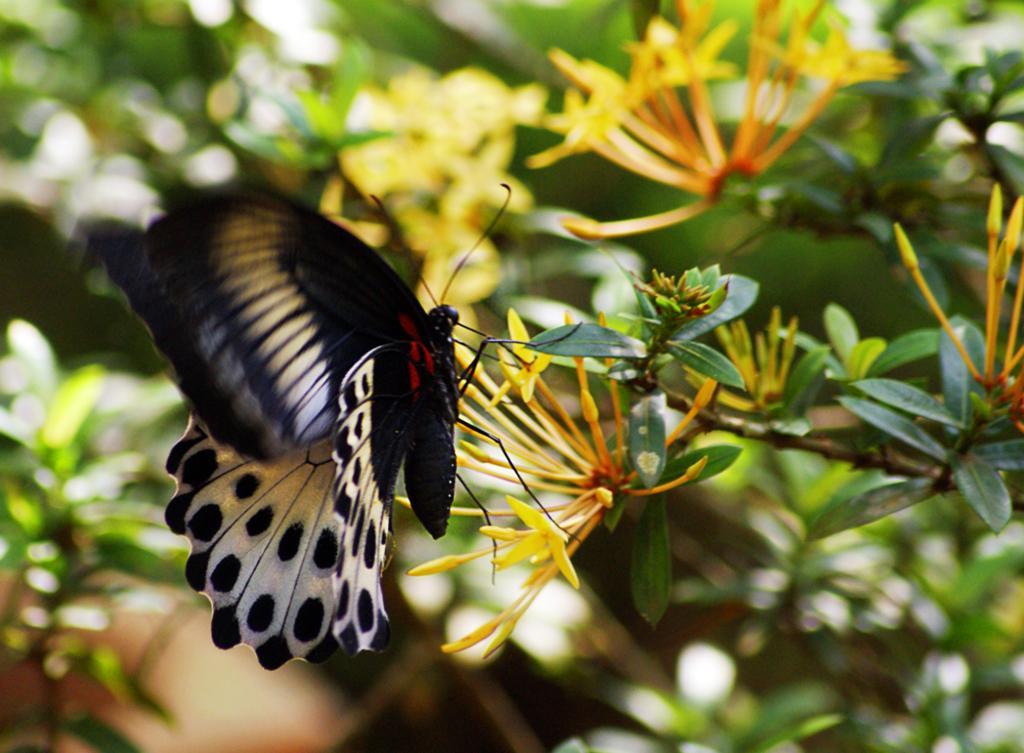Describe this image in one or two sentences. In this image we can see a butterfly on the flowers of a plant. 